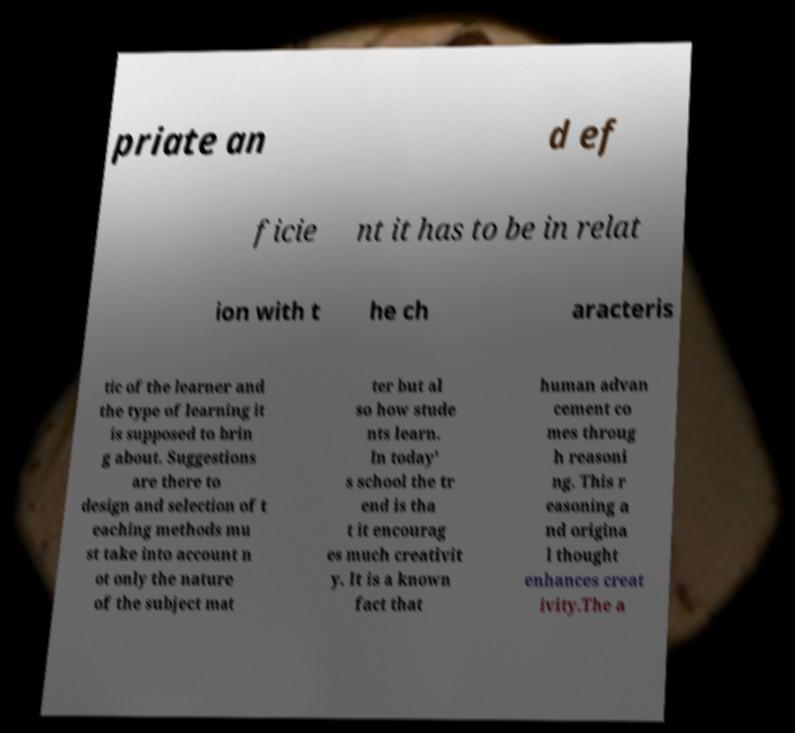What messages or text are displayed in this image? I need them in a readable, typed format. priate an d ef ficie nt it has to be in relat ion with t he ch aracteris tic of the learner and the type of learning it is supposed to brin g about. Suggestions are there to design and selection of t eaching methods mu st take into account n ot only the nature of the subject mat ter but al so how stude nts learn. In today' s school the tr end is tha t it encourag es much creativit y. It is a known fact that human advan cement co mes throug h reasoni ng. This r easoning a nd origina l thought enhances creat ivity.The a 